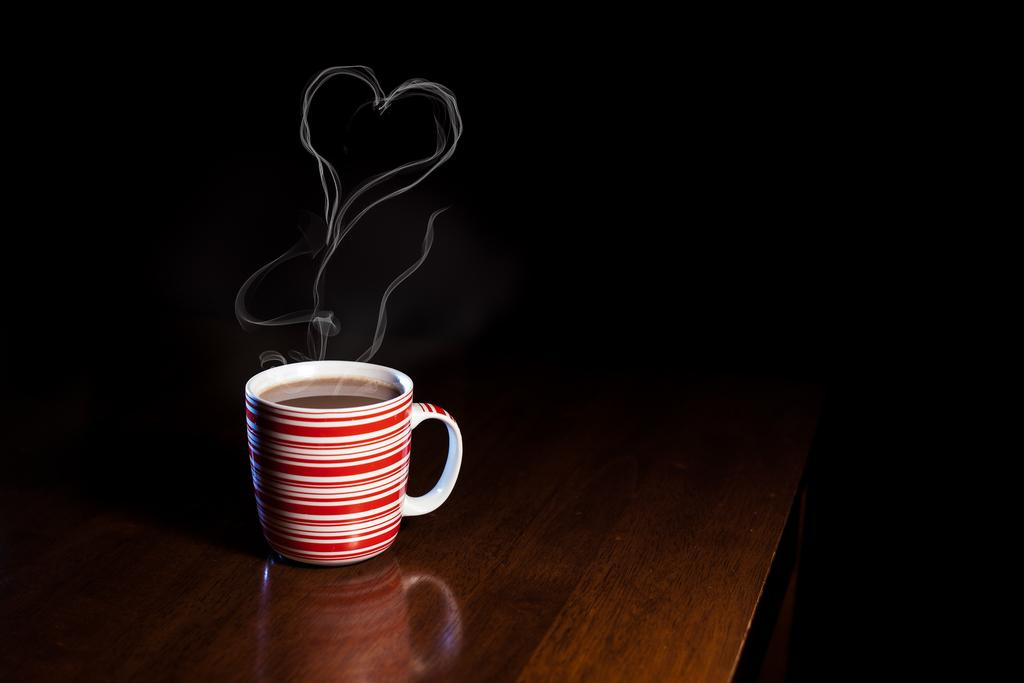What piece of furniture is present in the image? There is a table in the image. What is on the table in the image? There is a cup of coffee on the table. What can be seen in the air around the table? Vapor is visible in the air. What direction is the art pointing in the image? There is no art present in the image, so it is not possible to determine the direction it might be pointing. 